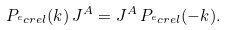<formula> <loc_0><loc_0><loc_500><loc_500>P _ { ^ { e } c r e l } ( k ) \, J ^ { A } = J ^ { A } \, P _ { ^ { e } c r e l } ( - k ) .</formula> 